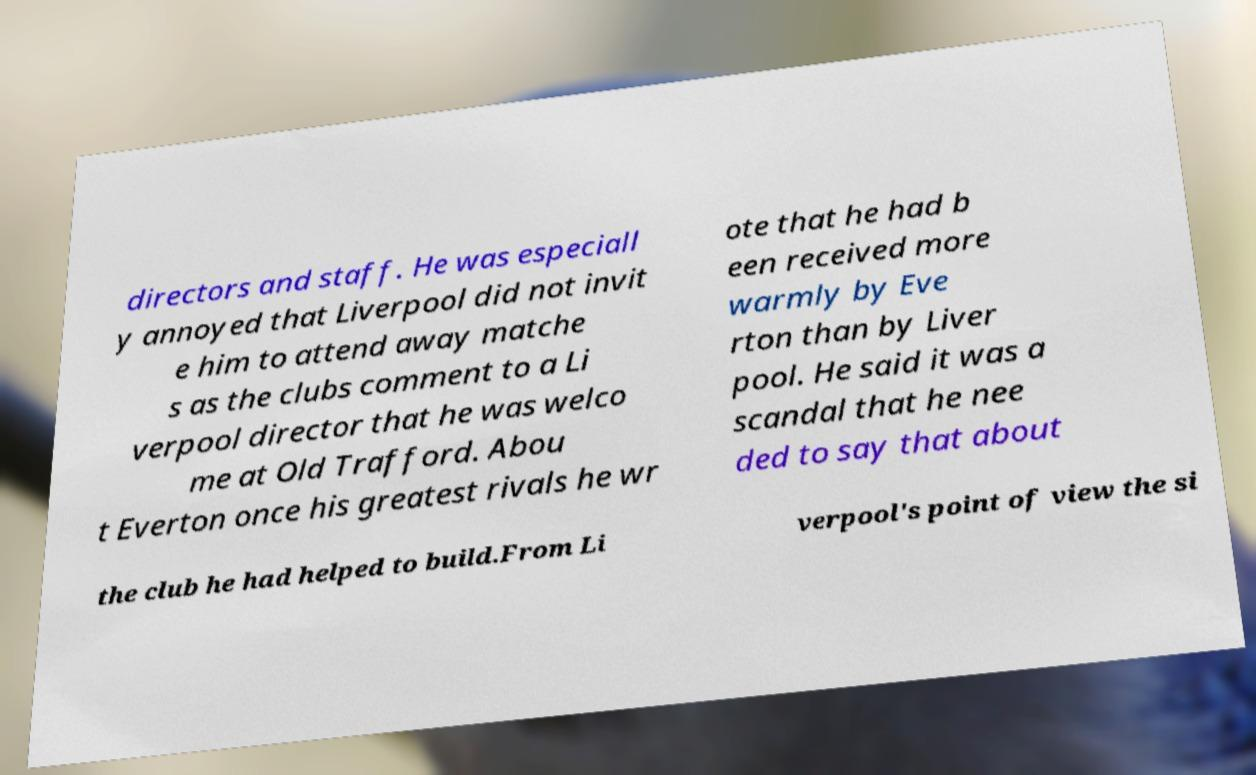Please read and relay the text visible in this image. What does it say? directors and staff. He was especiall y annoyed that Liverpool did not invit e him to attend away matche s as the clubs comment to a Li verpool director that he was welco me at Old Trafford. Abou t Everton once his greatest rivals he wr ote that he had b een received more warmly by Eve rton than by Liver pool. He said it was a scandal that he nee ded to say that about the club he had helped to build.From Li verpool's point of view the si 